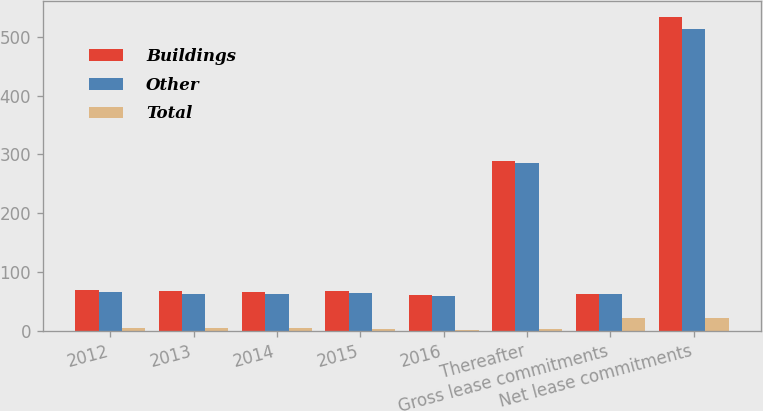<chart> <loc_0><loc_0><loc_500><loc_500><stacked_bar_chart><ecel><fcel>2012<fcel>2013<fcel>2014<fcel>2015<fcel>2016<fcel>Thereafter<fcel>Gross lease commitments<fcel>Net lease commitments<nl><fcel>Buildings<fcel>69.4<fcel>67<fcel>66.1<fcel>66.9<fcel>60.1<fcel>288.5<fcel>62.3<fcel>533.8<nl><fcel>Other<fcel>65<fcel>62.7<fcel>61.9<fcel>63.5<fcel>58.3<fcel>285.8<fcel>62.3<fcel>513<nl><fcel>Total<fcel>4.4<fcel>4.3<fcel>4.2<fcel>3.4<fcel>1.8<fcel>2.7<fcel>20.8<fcel>20.8<nl></chart> 